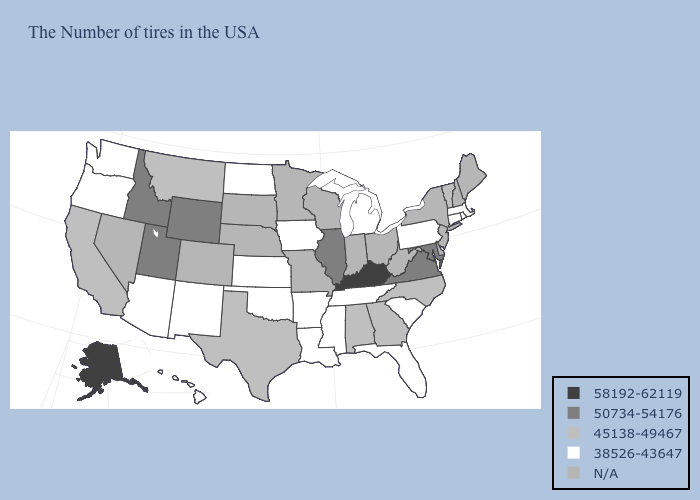Among the states that border South Carolina , which have the lowest value?
Give a very brief answer. North Carolina, Georgia. What is the value of West Virginia?
Keep it brief. N/A. What is the highest value in states that border Georgia?
Concise answer only. 45138-49467. Does Georgia have the lowest value in the USA?
Answer briefly. No. Name the states that have a value in the range 58192-62119?
Be succinct. Kentucky, Alaska. What is the value of Illinois?
Write a very short answer. 50734-54176. Among the states that border Arizona , which have the lowest value?
Answer briefly. New Mexico. What is the value of Missouri?
Answer briefly. N/A. What is the value of Hawaii?
Answer briefly. 38526-43647. How many symbols are there in the legend?
Write a very short answer. 5. What is the value of Indiana?
Concise answer only. N/A. How many symbols are there in the legend?
Give a very brief answer. 5. 